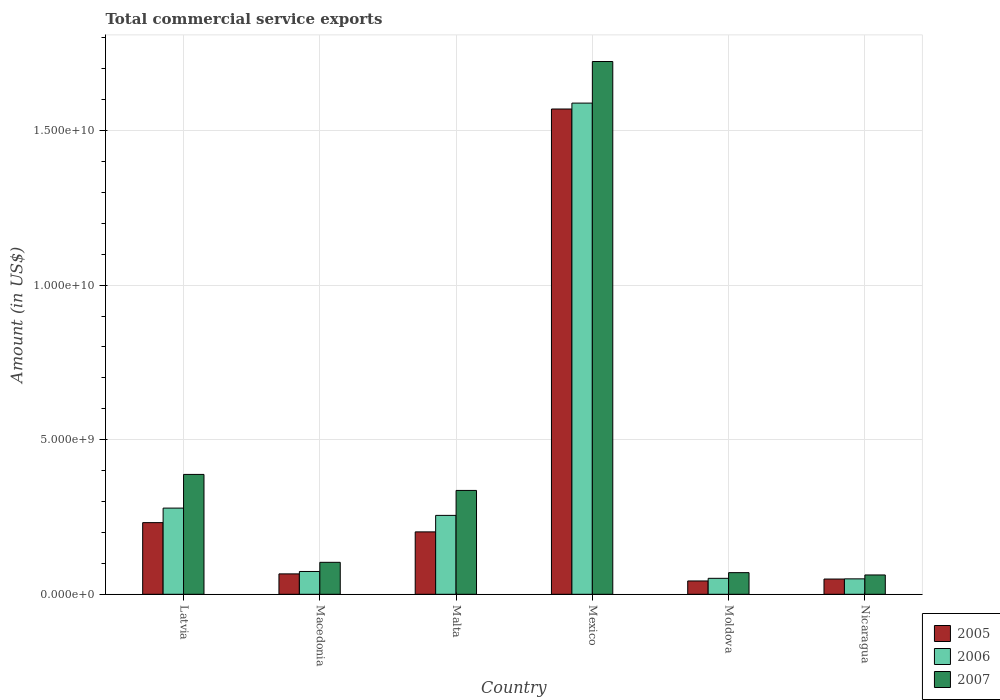How many different coloured bars are there?
Your answer should be very brief. 3. How many groups of bars are there?
Your answer should be compact. 6. Are the number of bars per tick equal to the number of legend labels?
Keep it short and to the point. Yes. How many bars are there on the 3rd tick from the right?
Your response must be concise. 3. What is the total commercial service exports in 2007 in Malta?
Offer a very short reply. 3.36e+09. Across all countries, what is the maximum total commercial service exports in 2005?
Ensure brevity in your answer.  1.57e+1. Across all countries, what is the minimum total commercial service exports in 2005?
Give a very brief answer. 4.31e+08. In which country was the total commercial service exports in 2005 minimum?
Give a very brief answer. Moldova. What is the total total commercial service exports in 2006 in the graph?
Keep it short and to the point. 2.30e+1. What is the difference between the total commercial service exports in 2006 in Mexico and that in Nicaragua?
Make the answer very short. 1.54e+1. What is the difference between the total commercial service exports in 2006 in Latvia and the total commercial service exports in 2005 in Macedonia?
Your answer should be very brief. 2.13e+09. What is the average total commercial service exports in 2007 per country?
Offer a very short reply. 4.47e+09. What is the difference between the total commercial service exports of/in 2005 and total commercial service exports of/in 2006 in Mexico?
Your answer should be compact. -1.91e+08. In how many countries, is the total commercial service exports in 2006 greater than 17000000000 US$?
Keep it short and to the point. 0. What is the ratio of the total commercial service exports in 2006 in Macedonia to that in Malta?
Your answer should be very brief. 0.29. Is the total commercial service exports in 2006 in Macedonia less than that in Mexico?
Your response must be concise. Yes. What is the difference between the highest and the second highest total commercial service exports in 2007?
Provide a short and direct response. -1.34e+1. What is the difference between the highest and the lowest total commercial service exports in 2006?
Provide a succinct answer. 1.54e+1. In how many countries, is the total commercial service exports in 2005 greater than the average total commercial service exports in 2005 taken over all countries?
Provide a short and direct response. 1. What does the 2nd bar from the right in Nicaragua represents?
Make the answer very short. 2006. How many bars are there?
Give a very brief answer. 18. Are all the bars in the graph horizontal?
Offer a very short reply. No. Are the values on the major ticks of Y-axis written in scientific E-notation?
Your response must be concise. Yes. Does the graph contain any zero values?
Offer a very short reply. No. Does the graph contain grids?
Provide a short and direct response. Yes. How many legend labels are there?
Your answer should be very brief. 3. What is the title of the graph?
Provide a short and direct response. Total commercial service exports. Does "2013" appear as one of the legend labels in the graph?
Provide a succinct answer. No. What is the label or title of the X-axis?
Offer a terse response. Country. What is the label or title of the Y-axis?
Give a very brief answer. Amount (in US$). What is the Amount (in US$) of 2005 in Latvia?
Keep it short and to the point. 2.32e+09. What is the Amount (in US$) of 2006 in Latvia?
Keep it short and to the point. 2.79e+09. What is the Amount (in US$) of 2007 in Latvia?
Offer a terse response. 3.88e+09. What is the Amount (in US$) in 2005 in Macedonia?
Keep it short and to the point. 6.60e+08. What is the Amount (in US$) in 2006 in Macedonia?
Your answer should be compact. 7.38e+08. What is the Amount (in US$) in 2007 in Macedonia?
Provide a succinct answer. 1.03e+09. What is the Amount (in US$) of 2005 in Malta?
Your answer should be very brief. 2.02e+09. What is the Amount (in US$) in 2006 in Malta?
Your answer should be compact. 2.55e+09. What is the Amount (in US$) of 2007 in Malta?
Your answer should be very brief. 3.36e+09. What is the Amount (in US$) of 2005 in Mexico?
Your response must be concise. 1.57e+1. What is the Amount (in US$) of 2006 in Mexico?
Give a very brief answer. 1.59e+1. What is the Amount (in US$) in 2007 in Mexico?
Ensure brevity in your answer.  1.72e+1. What is the Amount (in US$) of 2005 in Moldova?
Provide a short and direct response. 4.31e+08. What is the Amount (in US$) of 2006 in Moldova?
Your response must be concise. 5.17e+08. What is the Amount (in US$) of 2007 in Moldova?
Provide a succinct answer. 7.00e+08. What is the Amount (in US$) in 2005 in Nicaragua?
Keep it short and to the point. 4.93e+08. What is the Amount (in US$) of 2006 in Nicaragua?
Give a very brief answer. 5.00e+08. What is the Amount (in US$) of 2007 in Nicaragua?
Offer a very short reply. 6.25e+08. Across all countries, what is the maximum Amount (in US$) of 2005?
Make the answer very short. 1.57e+1. Across all countries, what is the maximum Amount (in US$) of 2006?
Provide a succinct answer. 1.59e+1. Across all countries, what is the maximum Amount (in US$) of 2007?
Offer a terse response. 1.72e+1. Across all countries, what is the minimum Amount (in US$) in 2005?
Offer a terse response. 4.31e+08. Across all countries, what is the minimum Amount (in US$) of 2006?
Keep it short and to the point. 5.00e+08. Across all countries, what is the minimum Amount (in US$) of 2007?
Give a very brief answer. 6.25e+08. What is the total Amount (in US$) of 2005 in the graph?
Offer a very short reply. 2.16e+1. What is the total Amount (in US$) in 2006 in the graph?
Your answer should be very brief. 2.30e+1. What is the total Amount (in US$) of 2007 in the graph?
Make the answer very short. 2.68e+1. What is the difference between the Amount (in US$) of 2005 in Latvia and that in Macedonia?
Provide a succinct answer. 1.66e+09. What is the difference between the Amount (in US$) in 2006 in Latvia and that in Macedonia?
Your answer should be compact. 2.05e+09. What is the difference between the Amount (in US$) in 2007 in Latvia and that in Macedonia?
Make the answer very short. 2.84e+09. What is the difference between the Amount (in US$) in 2005 in Latvia and that in Malta?
Your answer should be very brief. 2.99e+08. What is the difference between the Amount (in US$) in 2006 in Latvia and that in Malta?
Your answer should be very brief. 2.36e+08. What is the difference between the Amount (in US$) in 2007 in Latvia and that in Malta?
Provide a short and direct response. 5.18e+08. What is the difference between the Amount (in US$) in 2005 in Latvia and that in Mexico?
Provide a succinct answer. -1.34e+1. What is the difference between the Amount (in US$) in 2006 in Latvia and that in Mexico?
Offer a very short reply. -1.31e+1. What is the difference between the Amount (in US$) in 2007 in Latvia and that in Mexico?
Ensure brevity in your answer.  -1.34e+1. What is the difference between the Amount (in US$) in 2005 in Latvia and that in Moldova?
Ensure brevity in your answer.  1.89e+09. What is the difference between the Amount (in US$) in 2006 in Latvia and that in Moldova?
Provide a short and direct response. 2.27e+09. What is the difference between the Amount (in US$) of 2007 in Latvia and that in Moldova?
Keep it short and to the point. 3.18e+09. What is the difference between the Amount (in US$) in 2005 in Latvia and that in Nicaragua?
Ensure brevity in your answer.  1.82e+09. What is the difference between the Amount (in US$) in 2006 in Latvia and that in Nicaragua?
Provide a short and direct response. 2.29e+09. What is the difference between the Amount (in US$) in 2007 in Latvia and that in Nicaragua?
Keep it short and to the point. 3.25e+09. What is the difference between the Amount (in US$) of 2005 in Macedonia and that in Malta?
Offer a very short reply. -1.36e+09. What is the difference between the Amount (in US$) of 2006 in Macedonia and that in Malta?
Your response must be concise. -1.81e+09. What is the difference between the Amount (in US$) of 2007 in Macedonia and that in Malta?
Make the answer very short. -2.33e+09. What is the difference between the Amount (in US$) of 2005 in Macedonia and that in Mexico?
Offer a very short reply. -1.50e+1. What is the difference between the Amount (in US$) of 2006 in Macedonia and that in Mexico?
Your response must be concise. -1.52e+1. What is the difference between the Amount (in US$) in 2007 in Macedonia and that in Mexico?
Your answer should be very brief. -1.62e+1. What is the difference between the Amount (in US$) in 2005 in Macedonia and that in Moldova?
Your response must be concise. 2.29e+08. What is the difference between the Amount (in US$) in 2006 in Macedonia and that in Moldova?
Provide a short and direct response. 2.21e+08. What is the difference between the Amount (in US$) in 2007 in Macedonia and that in Moldova?
Give a very brief answer. 3.34e+08. What is the difference between the Amount (in US$) of 2005 in Macedonia and that in Nicaragua?
Offer a terse response. 1.67e+08. What is the difference between the Amount (in US$) of 2006 in Macedonia and that in Nicaragua?
Offer a terse response. 2.38e+08. What is the difference between the Amount (in US$) in 2007 in Macedonia and that in Nicaragua?
Your answer should be compact. 4.09e+08. What is the difference between the Amount (in US$) in 2005 in Malta and that in Mexico?
Provide a short and direct response. -1.37e+1. What is the difference between the Amount (in US$) of 2006 in Malta and that in Mexico?
Give a very brief answer. -1.33e+1. What is the difference between the Amount (in US$) in 2007 in Malta and that in Mexico?
Ensure brevity in your answer.  -1.39e+1. What is the difference between the Amount (in US$) of 2005 in Malta and that in Moldova?
Your answer should be very brief. 1.59e+09. What is the difference between the Amount (in US$) of 2006 in Malta and that in Moldova?
Ensure brevity in your answer.  2.04e+09. What is the difference between the Amount (in US$) of 2007 in Malta and that in Moldova?
Provide a succinct answer. 2.66e+09. What is the difference between the Amount (in US$) of 2005 in Malta and that in Nicaragua?
Your answer should be very brief. 1.53e+09. What is the difference between the Amount (in US$) in 2006 in Malta and that in Nicaragua?
Your answer should be compact. 2.05e+09. What is the difference between the Amount (in US$) of 2007 in Malta and that in Nicaragua?
Make the answer very short. 2.73e+09. What is the difference between the Amount (in US$) in 2005 in Mexico and that in Moldova?
Keep it short and to the point. 1.53e+1. What is the difference between the Amount (in US$) of 2006 in Mexico and that in Moldova?
Your response must be concise. 1.54e+1. What is the difference between the Amount (in US$) in 2007 in Mexico and that in Moldova?
Ensure brevity in your answer.  1.65e+1. What is the difference between the Amount (in US$) of 2005 in Mexico and that in Nicaragua?
Provide a short and direct response. 1.52e+1. What is the difference between the Amount (in US$) in 2006 in Mexico and that in Nicaragua?
Provide a short and direct response. 1.54e+1. What is the difference between the Amount (in US$) of 2007 in Mexico and that in Nicaragua?
Keep it short and to the point. 1.66e+1. What is the difference between the Amount (in US$) of 2005 in Moldova and that in Nicaragua?
Your response must be concise. -6.21e+07. What is the difference between the Amount (in US$) of 2006 in Moldova and that in Nicaragua?
Keep it short and to the point. 1.72e+07. What is the difference between the Amount (in US$) of 2007 in Moldova and that in Nicaragua?
Keep it short and to the point. 7.50e+07. What is the difference between the Amount (in US$) of 2005 in Latvia and the Amount (in US$) of 2006 in Macedonia?
Your answer should be compact. 1.58e+09. What is the difference between the Amount (in US$) in 2005 in Latvia and the Amount (in US$) in 2007 in Macedonia?
Offer a very short reply. 1.28e+09. What is the difference between the Amount (in US$) of 2006 in Latvia and the Amount (in US$) of 2007 in Macedonia?
Your answer should be compact. 1.75e+09. What is the difference between the Amount (in US$) of 2005 in Latvia and the Amount (in US$) of 2006 in Malta?
Your answer should be very brief. -2.35e+08. What is the difference between the Amount (in US$) of 2005 in Latvia and the Amount (in US$) of 2007 in Malta?
Your answer should be very brief. -1.04e+09. What is the difference between the Amount (in US$) in 2006 in Latvia and the Amount (in US$) in 2007 in Malta?
Your answer should be compact. -5.71e+08. What is the difference between the Amount (in US$) of 2005 in Latvia and the Amount (in US$) of 2006 in Mexico?
Keep it short and to the point. -1.36e+1. What is the difference between the Amount (in US$) of 2005 in Latvia and the Amount (in US$) of 2007 in Mexico?
Provide a short and direct response. -1.49e+1. What is the difference between the Amount (in US$) of 2006 in Latvia and the Amount (in US$) of 2007 in Mexico?
Your answer should be compact. -1.44e+1. What is the difference between the Amount (in US$) in 2005 in Latvia and the Amount (in US$) in 2006 in Moldova?
Your answer should be compact. 1.80e+09. What is the difference between the Amount (in US$) of 2005 in Latvia and the Amount (in US$) of 2007 in Moldova?
Provide a succinct answer. 1.62e+09. What is the difference between the Amount (in US$) in 2006 in Latvia and the Amount (in US$) in 2007 in Moldova?
Provide a short and direct response. 2.09e+09. What is the difference between the Amount (in US$) in 2005 in Latvia and the Amount (in US$) in 2006 in Nicaragua?
Your answer should be compact. 1.82e+09. What is the difference between the Amount (in US$) in 2005 in Latvia and the Amount (in US$) in 2007 in Nicaragua?
Offer a terse response. 1.69e+09. What is the difference between the Amount (in US$) in 2006 in Latvia and the Amount (in US$) in 2007 in Nicaragua?
Provide a short and direct response. 2.16e+09. What is the difference between the Amount (in US$) in 2005 in Macedonia and the Amount (in US$) in 2006 in Malta?
Your response must be concise. -1.89e+09. What is the difference between the Amount (in US$) in 2005 in Macedonia and the Amount (in US$) in 2007 in Malta?
Make the answer very short. -2.70e+09. What is the difference between the Amount (in US$) in 2006 in Macedonia and the Amount (in US$) in 2007 in Malta?
Make the answer very short. -2.62e+09. What is the difference between the Amount (in US$) of 2005 in Macedonia and the Amount (in US$) of 2006 in Mexico?
Your response must be concise. -1.52e+1. What is the difference between the Amount (in US$) in 2005 in Macedonia and the Amount (in US$) in 2007 in Mexico?
Your answer should be compact. -1.66e+1. What is the difference between the Amount (in US$) of 2006 in Macedonia and the Amount (in US$) of 2007 in Mexico?
Offer a terse response. -1.65e+1. What is the difference between the Amount (in US$) of 2005 in Macedonia and the Amount (in US$) of 2006 in Moldova?
Offer a very short reply. 1.44e+08. What is the difference between the Amount (in US$) in 2005 in Macedonia and the Amount (in US$) in 2007 in Moldova?
Give a very brief answer. -4.00e+07. What is the difference between the Amount (in US$) of 2006 in Macedonia and the Amount (in US$) of 2007 in Moldova?
Your answer should be compact. 3.76e+07. What is the difference between the Amount (in US$) in 2005 in Macedonia and the Amount (in US$) in 2006 in Nicaragua?
Offer a terse response. 1.61e+08. What is the difference between the Amount (in US$) of 2005 in Macedonia and the Amount (in US$) of 2007 in Nicaragua?
Your answer should be compact. 3.50e+07. What is the difference between the Amount (in US$) of 2006 in Macedonia and the Amount (in US$) of 2007 in Nicaragua?
Provide a succinct answer. 1.13e+08. What is the difference between the Amount (in US$) of 2005 in Malta and the Amount (in US$) of 2006 in Mexico?
Your answer should be compact. -1.39e+1. What is the difference between the Amount (in US$) of 2005 in Malta and the Amount (in US$) of 2007 in Mexico?
Your response must be concise. -1.52e+1. What is the difference between the Amount (in US$) in 2006 in Malta and the Amount (in US$) in 2007 in Mexico?
Your response must be concise. -1.47e+1. What is the difference between the Amount (in US$) in 2005 in Malta and the Amount (in US$) in 2006 in Moldova?
Provide a short and direct response. 1.50e+09. What is the difference between the Amount (in US$) of 2005 in Malta and the Amount (in US$) of 2007 in Moldova?
Keep it short and to the point. 1.32e+09. What is the difference between the Amount (in US$) of 2006 in Malta and the Amount (in US$) of 2007 in Moldova?
Your response must be concise. 1.85e+09. What is the difference between the Amount (in US$) in 2005 in Malta and the Amount (in US$) in 2006 in Nicaragua?
Your answer should be compact. 1.52e+09. What is the difference between the Amount (in US$) of 2005 in Malta and the Amount (in US$) of 2007 in Nicaragua?
Your answer should be compact. 1.39e+09. What is the difference between the Amount (in US$) of 2006 in Malta and the Amount (in US$) of 2007 in Nicaragua?
Ensure brevity in your answer.  1.93e+09. What is the difference between the Amount (in US$) in 2005 in Mexico and the Amount (in US$) in 2006 in Moldova?
Provide a succinct answer. 1.52e+1. What is the difference between the Amount (in US$) of 2005 in Mexico and the Amount (in US$) of 2007 in Moldova?
Ensure brevity in your answer.  1.50e+1. What is the difference between the Amount (in US$) of 2006 in Mexico and the Amount (in US$) of 2007 in Moldova?
Your answer should be compact. 1.52e+1. What is the difference between the Amount (in US$) in 2005 in Mexico and the Amount (in US$) in 2006 in Nicaragua?
Give a very brief answer. 1.52e+1. What is the difference between the Amount (in US$) in 2005 in Mexico and the Amount (in US$) in 2007 in Nicaragua?
Your response must be concise. 1.51e+1. What is the difference between the Amount (in US$) in 2006 in Mexico and the Amount (in US$) in 2007 in Nicaragua?
Your answer should be very brief. 1.53e+1. What is the difference between the Amount (in US$) of 2005 in Moldova and the Amount (in US$) of 2006 in Nicaragua?
Provide a short and direct response. -6.83e+07. What is the difference between the Amount (in US$) in 2005 in Moldova and the Amount (in US$) in 2007 in Nicaragua?
Provide a succinct answer. -1.94e+08. What is the difference between the Amount (in US$) in 2006 in Moldova and the Amount (in US$) in 2007 in Nicaragua?
Provide a short and direct response. -1.09e+08. What is the average Amount (in US$) in 2005 per country?
Offer a terse response. 3.60e+09. What is the average Amount (in US$) in 2006 per country?
Provide a short and direct response. 3.83e+09. What is the average Amount (in US$) of 2007 per country?
Ensure brevity in your answer.  4.47e+09. What is the difference between the Amount (in US$) of 2005 and Amount (in US$) of 2006 in Latvia?
Give a very brief answer. -4.70e+08. What is the difference between the Amount (in US$) of 2005 and Amount (in US$) of 2007 in Latvia?
Keep it short and to the point. -1.56e+09. What is the difference between the Amount (in US$) in 2006 and Amount (in US$) in 2007 in Latvia?
Provide a succinct answer. -1.09e+09. What is the difference between the Amount (in US$) of 2005 and Amount (in US$) of 2006 in Macedonia?
Provide a short and direct response. -7.75e+07. What is the difference between the Amount (in US$) of 2005 and Amount (in US$) of 2007 in Macedonia?
Offer a very short reply. -3.74e+08. What is the difference between the Amount (in US$) of 2006 and Amount (in US$) of 2007 in Macedonia?
Your answer should be very brief. -2.96e+08. What is the difference between the Amount (in US$) in 2005 and Amount (in US$) in 2006 in Malta?
Ensure brevity in your answer.  -5.34e+08. What is the difference between the Amount (in US$) of 2005 and Amount (in US$) of 2007 in Malta?
Make the answer very short. -1.34e+09. What is the difference between the Amount (in US$) in 2006 and Amount (in US$) in 2007 in Malta?
Provide a succinct answer. -8.07e+08. What is the difference between the Amount (in US$) in 2005 and Amount (in US$) in 2006 in Mexico?
Give a very brief answer. -1.91e+08. What is the difference between the Amount (in US$) in 2005 and Amount (in US$) in 2007 in Mexico?
Keep it short and to the point. -1.54e+09. What is the difference between the Amount (in US$) in 2006 and Amount (in US$) in 2007 in Mexico?
Keep it short and to the point. -1.35e+09. What is the difference between the Amount (in US$) of 2005 and Amount (in US$) of 2006 in Moldova?
Offer a terse response. -8.55e+07. What is the difference between the Amount (in US$) of 2005 and Amount (in US$) of 2007 in Moldova?
Make the answer very short. -2.69e+08. What is the difference between the Amount (in US$) in 2006 and Amount (in US$) in 2007 in Moldova?
Offer a terse response. -1.84e+08. What is the difference between the Amount (in US$) in 2005 and Amount (in US$) in 2006 in Nicaragua?
Offer a very short reply. -6.20e+06. What is the difference between the Amount (in US$) in 2005 and Amount (in US$) in 2007 in Nicaragua?
Your answer should be very brief. -1.32e+08. What is the difference between the Amount (in US$) of 2006 and Amount (in US$) of 2007 in Nicaragua?
Make the answer very short. -1.26e+08. What is the ratio of the Amount (in US$) of 2005 in Latvia to that in Macedonia?
Offer a terse response. 3.51. What is the ratio of the Amount (in US$) in 2006 in Latvia to that in Macedonia?
Your answer should be compact. 3.78. What is the ratio of the Amount (in US$) of 2007 in Latvia to that in Macedonia?
Keep it short and to the point. 3.75. What is the ratio of the Amount (in US$) in 2005 in Latvia to that in Malta?
Your answer should be compact. 1.15. What is the ratio of the Amount (in US$) in 2006 in Latvia to that in Malta?
Your answer should be compact. 1.09. What is the ratio of the Amount (in US$) in 2007 in Latvia to that in Malta?
Make the answer very short. 1.15. What is the ratio of the Amount (in US$) in 2005 in Latvia to that in Mexico?
Provide a short and direct response. 0.15. What is the ratio of the Amount (in US$) in 2006 in Latvia to that in Mexico?
Make the answer very short. 0.18. What is the ratio of the Amount (in US$) in 2007 in Latvia to that in Mexico?
Make the answer very short. 0.23. What is the ratio of the Amount (in US$) in 2005 in Latvia to that in Moldova?
Offer a very short reply. 5.37. What is the ratio of the Amount (in US$) in 2006 in Latvia to that in Moldova?
Your answer should be compact. 5.39. What is the ratio of the Amount (in US$) of 2007 in Latvia to that in Moldova?
Your answer should be compact. 5.54. What is the ratio of the Amount (in US$) in 2005 in Latvia to that in Nicaragua?
Ensure brevity in your answer.  4.7. What is the ratio of the Amount (in US$) in 2006 in Latvia to that in Nicaragua?
Your answer should be very brief. 5.58. What is the ratio of the Amount (in US$) in 2007 in Latvia to that in Nicaragua?
Make the answer very short. 6.2. What is the ratio of the Amount (in US$) in 2005 in Macedonia to that in Malta?
Your answer should be compact. 0.33. What is the ratio of the Amount (in US$) of 2006 in Macedonia to that in Malta?
Your response must be concise. 0.29. What is the ratio of the Amount (in US$) in 2007 in Macedonia to that in Malta?
Offer a terse response. 0.31. What is the ratio of the Amount (in US$) in 2005 in Macedonia to that in Mexico?
Provide a succinct answer. 0.04. What is the ratio of the Amount (in US$) of 2006 in Macedonia to that in Mexico?
Offer a terse response. 0.05. What is the ratio of the Amount (in US$) of 2005 in Macedonia to that in Moldova?
Ensure brevity in your answer.  1.53. What is the ratio of the Amount (in US$) in 2006 in Macedonia to that in Moldova?
Keep it short and to the point. 1.43. What is the ratio of the Amount (in US$) in 2007 in Macedonia to that in Moldova?
Make the answer very short. 1.48. What is the ratio of the Amount (in US$) in 2005 in Macedonia to that in Nicaragua?
Your answer should be compact. 1.34. What is the ratio of the Amount (in US$) of 2006 in Macedonia to that in Nicaragua?
Your answer should be very brief. 1.48. What is the ratio of the Amount (in US$) in 2007 in Macedonia to that in Nicaragua?
Make the answer very short. 1.65. What is the ratio of the Amount (in US$) in 2005 in Malta to that in Mexico?
Provide a succinct answer. 0.13. What is the ratio of the Amount (in US$) of 2006 in Malta to that in Mexico?
Your answer should be compact. 0.16. What is the ratio of the Amount (in US$) of 2007 in Malta to that in Mexico?
Provide a short and direct response. 0.2. What is the ratio of the Amount (in US$) in 2005 in Malta to that in Moldova?
Provide a short and direct response. 4.68. What is the ratio of the Amount (in US$) of 2006 in Malta to that in Moldova?
Provide a short and direct response. 4.94. What is the ratio of the Amount (in US$) of 2007 in Malta to that in Moldova?
Offer a terse response. 4.8. What is the ratio of the Amount (in US$) of 2005 in Malta to that in Nicaragua?
Your answer should be very brief. 4.09. What is the ratio of the Amount (in US$) of 2006 in Malta to that in Nicaragua?
Your answer should be very brief. 5.11. What is the ratio of the Amount (in US$) in 2007 in Malta to that in Nicaragua?
Keep it short and to the point. 5.37. What is the ratio of the Amount (in US$) of 2005 in Mexico to that in Moldova?
Provide a succinct answer. 36.39. What is the ratio of the Amount (in US$) in 2006 in Mexico to that in Moldova?
Offer a terse response. 30.74. What is the ratio of the Amount (in US$) in 2007 in Mexico to that in Moldova?
Keep it short and to the point. 24.61. What is the ratio of the Amount (in US$) in 2005 in Mexico to that in Nicaragua?
Your response must be concise. 31.81. What is the ratio of the Amount (in US$) of 2006 in Mexico to that in Nicaragua?
Your response must be concise. 31.8. What is the ratio of the Amount (in US$) of 2007 in Mexico to that in Nicaragua?
Your answer should be very brief. 27.56. What is the ratio of the Amount (in US$) of 2005 in Moldova to that in Nicaragua?
Make the answer very short. 0.87. What is the ratio of the Amount (in US$) in 2006 in Moldova to that in Nicaragua?
Your answer should be very brief. 1.03. What is the ratio of the Amount (in US$) in 2007 in Moldova to that in Nicaragua?
Your answer should be compact. 1.12. What is the difference between the highest and the second highest Amount (in US$) in 2005?
Make the answer very short. 1.34e+1. What is the difference between the highest and the second highest Amount (in US$) of 2006?
Offer a terse response. 1.31e+1. What is the difference between the highest and the second highest Amount (in US$) in 2007?
Offer a very short reply. 1.34e+1. What is the difference between the highest and the lowest Amount (in US$) in 2005?
Provide a succinct answer. 1.53e+1. What is the difference between the highest and the lowest Amount (in US$) of 2006?
Provide a short and direct response. 1.54e+1. What is the difference between the highest and the lowest Amount (in US$) of 2007?
Ensure brevity in your answer.  1.66e+1. 